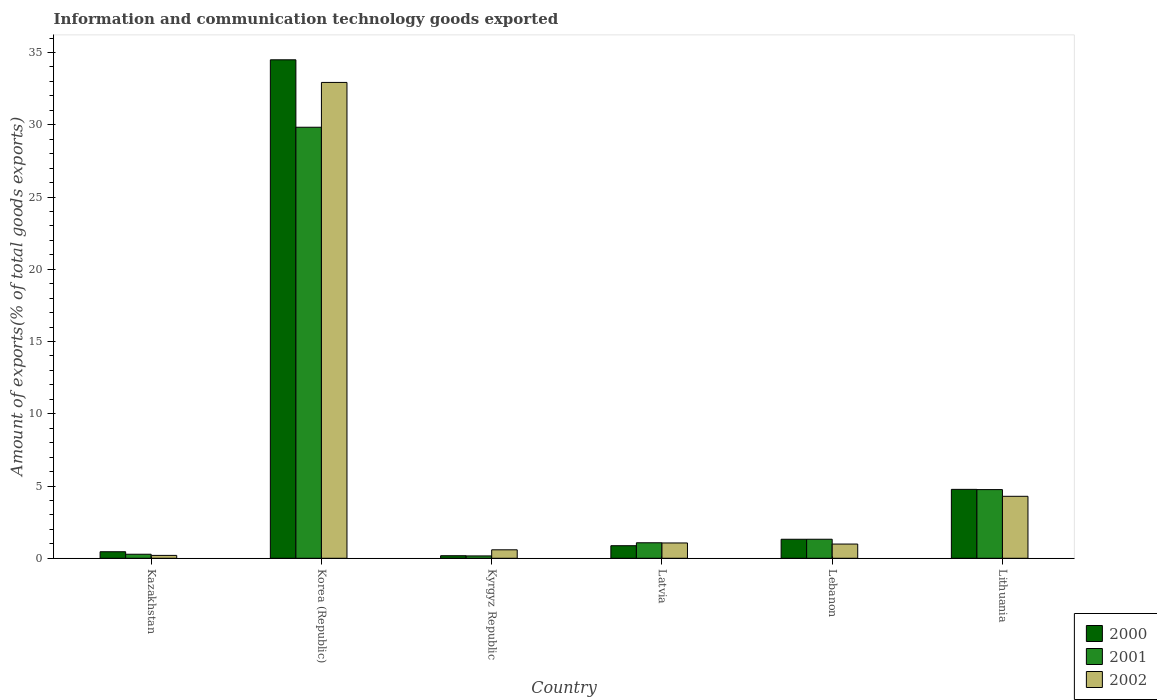Are the number of bars per tick equal to the number of legend labels?
Keep it short and to the point. Yes. How many bars are there on the 2nd tick from the left?
Your answer should be compact. 3. How many bars are there on the 5th tick from the right?
Offer a very short reply. 3. What is the label of the 3rd group of bars from the left?
Keep it short and to the point. Kyrgyz Republic. In how many cases, is the number of bars for a given country not equal to the number of legend labels?
Provide a short and direct response. 0. What is the amount of goods exported in 2002 in Korea (Republic)?
Ensure brevity in your answer.  32.93. Across all countries, what is the maximum amount of goods exported in 2001?
Provide a short and direct response. 29.83. Across all countries, what is the minimum amount of goods exported in 2001?
Your answer should be very brief. 0.16. In which country was the amount of goods exported in 2002 maximum?
Offer a very short reply. Korea (Republic). In which country was the amount of goods exported in 2002 minimum?
Your answer should be very brief. Kazakhstan. What is the total amount of goods exported in 2000 in the graph?
Keep it short and to the point. 42.08. What is the difference between the amount of goods exported in 2001 in Kazakhstan and that in Lithuania?
Ensure brevity in your answer.  -4.47. What is the difference between the amount of goods exported in 2002 in Lithuania and the amount of goods exported in 2000 in Lebanon?
Your answer should be compact. 2.97. What is the average amount of goods exported in 2002 per country?
Keep it short and to the point. 6.67. What is the difference between the amount of goods exported of/in 2001 and amount of goods exported of/in 2002 in Kazakhstan?
Keep it short and to the point. 0.08. What is the ratio of the amount of goods exported in 2002 in Kazakhstan to that in Kyrgyz Republic?
Provide a succinct answer. 0.34. Is the amount of goods exported in 2001 in Korea (Republic) less than that in Latvia?
Offer a terse response. No. What is the difference between the highest and the second highest amount of goods exported in 2000?
Offer a very short reply. -33.18. What is the difference between the highest and the lowest amount of goods exported in 2002?
Provide a succinct answer. 32.73. In how many countries, is the amount of goods exported in 2000 greater than the average amount of goods exported in 2000 taken over all countries?
Your response must be concise. 1. What does the 3rd bar from the left in Lithuania represents?
Offer a terse response. 2002. What does the 3rd bar from the right in Kazakhstan represents?
Your response must be concise. 2000. Is it the case that in every country, the sum of the amount of goods exported in 2002 and amount of goods exported in 2001 is greater than the amount of goods exported in 2000?
Offer a very short reply. Yes. How many bars are there?
Give a very brief answer. 18. Are all the bars in the graph horizontal?
Make the answer very short. No. Does the graph contain grids?
Provide a succinct answer. No. Where does the legend appear in the graph?
Give a very brief answer. Bottom right. How many legend labels are there?
Your answer should be very brief. 3. How are the legend labels stacked?
Provide a short and direct response. Vertical. What is the title of the graph?
Ensure brevity in your answer.  Information and communication technology goods exported. Does "1960" appear as one of the legend labels in the graph?
Offer a terse response. No. What is the label or title of the Y-axis?
Offer a terse response. Amount of exports(% of total goods exports). What is the Amount of exports(% of total goods exports) in 2000 in Kazakhstan?
Provide a short and direct response. 0.45. What is the Amount of exports(% of total goods exports) in 2001 in Kazakhstan?
Ensure brevity in your answer.  0.28. What is the Amount of exports(% of total goods exports) in 2002 in Kazakhstan?
Your answer should be very brief. 0.2. What is the Amount of exports(% of total goods exports) in 2000 in Korea (Republic)?
Your answer should be very brief. 34.5. What is the Amount of exports(% of total goods exports) in 2001 in Korea (Republic)?
Ensure brevity in your answer.  29.83. What is the Amount of exports(% of total goods exports) in 2002 in Korea (Republic)?
Provide a succinct answer. 32.93. What is the Amount of exports(% of total goods exports) in 2000 in Kyrgyz Republic?
Make the answer very short. 0.18. What is the Amount of exports(% of total goods exports) in 2001 in Kyrgyz Republic?
Give a very brief answer. 0.16. What is the Amount of exports(% of total goods exports) in 2002 in Kyrgyz Republic?
Provide a short and direct response. 0.59. What is the Amount of exports(% of total goods exports) of 2000 in Latvia?
Keep it short and to the point. 0.87. What is the Amount of exports(% of total goods exports) in 2001 in Latvia?
Your answer should be compact. 1.07. What is the Amount of exports(% of total goods exports) of 2002 in Latvia?
Offer a terse response. 1.06. What is the Amount of exports(% of total goods exports) of 2000 in Lebanon?
Offer a terse response. 1.32. What is the Amount of exports(% of total goods exports) in 2001 in Lebanon?
Your answer should be very brief. 1.32. What is the Amount of exports(% of total goods exports) in 2002 in Lebanon?
Give a very brief answer. 0.98. What is the Amount of exports(% of total goods exports) in 2000 in Lithuania?
Your response must be concise. 4.77. What is the Amount of exports(% of total goods exports) of 2001 in Lithuania?
Provide a short and direct response. 4.75. What is the Amount of exports(% of total goods exports) of 2002 in Lithuania?
Provide a short and direct response. 4.29. Across all countries, what is the maximum Amount of exports(% of total goods exports) in 2000?
Provide a short and direct response. 34.5. Across all countries, what is the maximum Amount of exports(% of total goods exports) in 2001?
Offer a very short reply. 29.83. Across all countries, what is the maximum Amount of exports(% of total goods exports) in 2002?
Your answer should be compact. 32.93. Across all countries, what is the minimum Amount of exports(% of total goods exports) in 2000?
Your response must be concise. 0.18. Across all countries, what is the minimum Amount of exports(% of total goods exports) in 2001?
Your response must be concise. 0.16. Across all countries, what is the minimum Amount of exports(% of total goods exports) in 2002?
Offer a terse response. 0.2. What is the total Amount of exports(% of total goods exports) of 2000 in the graph?
Provide a short and direct response. 42.08. What is the total Amount of exports(% of total goods exports) in 2001 in the graph?
Your answer should be very brief. 37.41. What is the total Amount of exports(% of total goods exports) in 2002 in the graph?
Your answer should be very brief. 40.05. What is the difference between the Amount of exports(% of total goods exports) of 2000 in Kazakhstan and that in Korea (Republic)?
Provide a short and direct response. -34.04. What is the difference between the Amount of exports(% of total goods exports) of 2001 in Kazakhstan and that in Korea (Republic)?
Your answer should be very brief. -29.55. What is the difference between the Amount of exports(% of total goods exports) of 2002 in Kazakhstan and that in Korea (Republic)?
Provide a succinct answer. -32.73. What is the difference between the Amount of exports(% of total goods exports) in 2000 in Kazakhstan and that in Kyrgyz Republic?
Offer a very short reply. 0.28. What is the difference between the Amount of exports(% of total goods exports) in 2001 in Kazakhstan and that in Kyrgyz Republic?
Your response must be concise. 0.12. What is the difference between the Amount of exports(% of total goods exports) of 2002 in Kazakhstan and that in Kyrgyz Republic?
Give a very brief answer. -0.39. What is the difference between the Amount of exports(% of total goods exports) in 2000 in Kazakhstan and that in Latvia?
Offer a terse response. -0.42. What is the difference between the Amount of exports(% of total goods exports) in 2001 in Kazakhstan and that in Latvia?
Give a very brief answer. -0.79. What is the difference between the Amount of exports(% of total goods exports) of 2002 in Kazakhstan and that in Latvia?
Provide a short and direct response. -0.86. What is the difference between the Amount of exports(% of total goods exports) in 2000 in Kazakhstan and that in Lebanon?
Offer a terse response. -0.86. What is the difference between the Amount of exports(% of total goods exports) of 2001 in Kazakhstan and that in Lebanon?
Give a very brief answer. -1.04. What is the difference between the Amount of exports(% of total goods exports) of 2002 in Kazakhstan and that in Lebanon?
Provide a short and direct response. -0.78. What is the difference between the Amount of exports(% of total goods exports) in 2000 in Kazakhstan and that in Lithuania?
Keep it short and to the point. -4.32. What is the difference between the Amount of exports(% of total goods exports) of 2001 in Kazakhstan and that in Lithuania?
Offer a terse response. -4.47. What is the difference between the Amount of exports(% of total goods exports) in 2002 in Kazakhstan and that in Lithuania?
Provide a short and direct response. -4.09. What is the difference between the Amount of exports(% of total goods exports) of 2000 in Korea (Republic) and that in Kyrgyz Republic?
Give a very brief answer. 34.32. What is the difference between the Amount of exports(% of total goods exports) of 2001 in Korea (Republic) and that in Kyrgyz Republic?
Your answer should be very brief. 29.67. What is the difference between the Amount of exports(% of total goods exports) of 2002 in Korea (Republic) and that in Kyrgyz Republic?
Your answer should be compact. 32.34. What is the difference between the Amount of exports(% of total goods exports) in 2000 in Korea (Republic) and that in Latvia?
Ensure brevity in your answer.  33.63. What is the difference between the Amount of exports(% of total goods exports) of 2001 in Korea (Republic) and that in Latvia?
Your response must be concise. 28.76. What is the difference between the Amount of exports(% of total goods exports) in 2002 in Korea (Republic) and that in Latvia?
Ensure brevity in your answer.  31.87. What is the difference between the Amount of exports(% of total goods exports) of 2000 in Korea (Republic) and that in Lebanon?
Give a very brief answer. 33.18. What is the difference between the Amount of exports(% of total goods exports) of 2001 in Korea (Republic) and that in Lebanon?
Offer a terse response. 28.51. What is the difference between the Amount of exports(% of total goods exports) of 2002 in Korea (Republic) and that in Lebanon?
Your response must be concise. 31.95. What is the difference between the Amount of exports(% of total goods exports) in 2000 in Korea (Republic) and that in Lithuania?
Your answer should be very brief. 29.73. What is the difference between the Amount of exports(% of total goods exports) of 2001 in Korea (Republic) and that in Lithuania?
Give a very brief answer. 25.08. What is the difference between the Amount of exports(% of total goods exports) of 2002 in Korea (Republic) and that in Lithuania?
Keep it short and to the point. 28.64. What is the difference between the Amount of exports(% of total goods exports) of 2000 in Kyrgyz Republic and that in Latvia?
Ensure brevity in your answer.  -0.69. What is the difference between the Amount of exports(% of total goods exports) in 2001 in Kyrgyz Republic and that in Latvia?
Offer a terse response. -0.91. What is the difference between the Amount of exports(% of total goods exports) of 2002 in Kyrgyz Republic and that in Latvia?
Provide a short and direct response. -0.47. What is the difference between the Amount of exports(% of total goods exports) in 2000 in Kyrgyz Republic and that in Lebanon?
Provide a succinct answer. -1.14. What is the difference between the Amount of exports(% of total goods exports) in 2001 in Kyrgyz Republic and that in Lebanon?
Provide a short and direct response. -1.15. What is the difference between the Amount of exports(% of total goods exports) in 2002 in Kyrgyz Republic and that in Lebanon?
Your answer should be compact. -0.4. What is the difference between the Amount of exports(% of total goods exports) in 2000 in Kyrgyz Republic and that in Lithuania?
Make the answer very short. -4.59. What is the difference between the Amount of exports(% of total goods exports) of 2001 in Kyrgyz Republic and that in Lithuania?
Ensure brevity in your answer.  -4.59. What is the difference between the Amount of exports(% of total goods exports) of 2002 in Kyrgyz Republic and that in Lithuania?
Give a very brief answer. -3.7. What is the difference between the Amount of exports(% of total goods exports) in 2000 in Latvia and that in Lebanon?
Ensure brevity in your answer.  -0.45. What is the difference between the Amount of exports(% of total goods exports) in 2001 in Latvia and that in Lebanon?
Your response must be concise. -0.24. What is the difference between the Amount of exports(% of total goods exports) in 2002 in Latvia and that in Lebanon?
Make the answer very short. 0.08. What is the difference between the Amount of exports(% of total goods exports) of 2000 in Latvia and that in Lithuania?
Ensure brevity in your answer.  -3.9. What is the difference between the Amount of exports(% of total goods exports) of 2001 in Latvia and that in Lithuania?
Your answer should be very brief. -3.68. What is the difference between the Amount of exports(% of total goods exports) in 2002 in Latvia and that in Lithuania?
Provide a short and direct response. -3.23. What is the difference between the Amount of exports(% of total goods exports) of 2000 in Lebanon and that in Lithuania?
Give a very brief answer. -3.45. What is the difference between the Amount of exports(% of total goods exports) of 2001 in Lebanon and that in Lithuania?
Your answer should be compact. -3.44. What is the difference between the Amount of exports(% of total goods exports) of 2002 in Lebanon and that in Lithuania?
Your answer should be very brief. -3.31. What is the difference between the Amount of exports(% of total goods exports) in 2000 in Kazakhstan and the Amount of exports(% of total goods exports) in 2001 in Korea (Republic)?
Provide a short and direct response. -29.38. What is the difference between the Amount of exports(% of total goods exports) of 2000 in Kazakhstan and the Amount of exports(% of total goods exports) of 2002 in Korea (Republic)?
Keep it short and to the point. -32.48. What is the difference between the Amount of exports(% of total goods exports) of 2001 in Kazakhstan and the Amount of exports(% of total goods exports) of 2002 in Korea (Republic)?
Make the answer very short. -32.65. What is the difference between the Amount of exports(% of total goods exports) in 2000 in Kazakhstan and the Amount of exports(% of total goods exports) in 2001 in Kyrgyz Republic?
Your response must be concise. 0.29. What is the difference between the Amount of exports(% of total goods exports) in 2000 in Kazakhstan and the Amount of exports(% of total goods exports) in 2002 in Kyrgyz Republic?
Offer a terse response. -0.13. What is the difference between the Amount of exports(% of total goods exports) of 2001 in Kazakhstan and the Amount of exports(% of total goods exports) of 2002 in Kyrgyz Republic?
Give a very brief answer. -0.31. What is the difference between the Amount of exports(% of total goods exports) in 2000 in Kazakhstan and the Amount of exports(% of total goods exports) in 2001 in Latvia?
Ensure brevity in your answer.  -0.62. What is the difference between the Amount of exports(% of total goods exports) in 2000 in Kazakhstan and the Amount of exports(% of total goods exports) in 2002 in Latvia?
Give a very brief answer. -0.61. What is the difference between the Amount of exports(% of total goods exports) of 2001 in Kazakhstan and the Amount of exports(% of total goods exports) of 2002 in Latvia?
Make the answer very short. -0.78. What is the difference between the Amount of exports(% of total goods exports) of 2000 in Kazakhstan and the Amount of exports(% of total goods exports) of 2001 in Lebanon?
Make the answer very short. -0.86. What is the difference between the Amount of exports(% of total goods exports) of 2000 in Kazakhstan and the Amount of exports(% of total goods exports) of 2002 in Lebanon?
Keep it short and to the point. -0.53. What is the difference between the Amount of exports(% of total goods exports) of 2001 in Kazakhstan and the Amount of exports(% of total goods exports) of 2002 in Lebanon?
Offer a very short reply. -0.7. What is the difference between the Amount of exports(% of total goods exports) of 2000 in Kazakhstan and the Amount of exports(% of total goods exports) of 2002 in Lithuania?
Provide a short and direct response. -3.84. What is the difference between the Amount of exports(% of total goods exports) in 2001 in Kazakhstan and the Amount of exports(% of total goods exports) in 2002 in Lithuania?
Give a very brief answer. -4.01. What is the difference between the Amount of exports(% of total goods exports) of 2000 in Korea (Republic) and the Amount of exports(% of total goods exports) of 2001 in Kyrgyz Republic?
Give a very brief answer. 34.33. What is the difference between the Amount of exports(% of total goods exports) of 2000 in Korea (Republic) and the Amount of exports(% of total goods exports) of 2002 in Kyrgyz Republic?
Provide a short and direct response. 33.91. What is the difference between the Amount of exports(% of total goods exports) in 2001 in Korea (Republic) and the Amount of exports(% of total goods exports) in 2002 in Kyrgyz Republic?
Your answer should be compact. 29.24. What is the difference between the Amount of exports(% of total goods exports) in 2000 in Korea (Republic) and the Amount of exports(% of total goods exports) in 2001 in Latvia?
Give a very brief answer. 33.42. What is the difference between the Amount of exports(% of total goods exports) in 2000 in Korea (Republic) and the Amount of exports(% of total goods exports) in 2002 in Latvia?
Provide a succinct answer. 33.44. What is the difference between the Amount of exports(% of total goods exports) in 2001 in Korea (Republic) and the Amount of exports(% of total goods exports) in 2002 in Latvia?
Your response must be concise. 28.77. What is the difference between the Amount of exports(% of total goods exports) of 2000 in Korea (Republic) and the Amount of exports(% of total goods exports) of 2001 in Lebanon?
Provide a succinct answer. 33.18. What is the difference between the Amount of exports(% of total goods exports) in 2000 in Korea (Republic) and the Amount of exports(% of total goods exports) in 2002 in Lebanon?
Provide a short and direct response. 33.51. What is the difference between the Amount of exports(% of total goods exports) in 2001 in Korea (Republic) and the Amount of exports(% of total goods exports) in 2002 in Lebanon?
Keep it short and to the point. 28.84. What is the difference between the Amount of exports(% of total goods exports) in 2000 in Korea (Republic) and the Amount of exports(% of total goods exports) in 2001 in Lithuania?
Offer a very short reply. 29.74. What is the difference between the Amount of exports(% of total goods exports) in 2000 in Korea (Republic) and the Amount of exports(% of total goods exports) in 2002 in Lithuania?
Provide a succinct answer. 30.21. What is the difference between the Amount of exports(% of total goods exports) in 2001 in Korea (Republic) and the Amount of exports(% of total goods exports) in 2002 in Lithuania?
Provide a short and direct response. 25.54. What is the difference between the Amount of exports(% of total goods exports) of 2000 in Kyrgyz Republic and the Amount of exports(% of total goods exports) of 2001 in Latvia?
Keep it short and to the point. -0.9. What is the difference between the Amount of exports(% of total goods exports) in 2000 in Kyrgyz Republic and the Amount of exports(% of total goods exports) in 2002 in Latvia?
Provide a short and direct response. -0.88. What is the difference between the Amount of exports(% of total goods exports) in 2001 in Kyrgyz Republic and the Amount of exports(% of total goods exports) in 2002 in Latvia?
Offer a terse response. -0.9. What is the difference between the Amount of exports(% of total goods exports) of 2000 in Kyrgyz Republic and the Amount of exports(% of total goods exports) of 2001 in Lebanon?
Provide a short and direct response. -1.14. What is the difference between the Amount of exports(% of total goods exports) of 2000 in Kyrgyz Republic and the Amount of exports(% of total goods exports) of 2002 in Lebanon?
Your response must be concise. -0.81. What is the difference between the Amount of exports(% of total goods exports) of 2001 in Kyrgyz Republic and the Amount of exports(% of total goods exports) of 2002 in Lebanon?
Give a very brief answer. -0.82. What is the difference between the Amount of exports(% of total goods exports) in 2000 in Kyrgyz Republic and the Amount of exports(% of total goods exports) in 2001 in Lithuania?
Your response must be concise. -4.58. What is the difference between the Amount of exports(% of total goods exports) in 2000 in Kyrgyz Republic and the Amount of exports(% of total goods exports) in 2002 in Lithuania?
Give a very brief answer. -4.11. What is the difference between the Amount of exports(% of total goods exports) of 2001 in Kyrgyz Republic and the Amount of exports(% of total goods exports) of 2002 in Lithuania?
Make the answer very short. -4.13. What is the difference between the Amount of exports(% of total goods exports) in 2000 in Latvia and the Amount of exports(% of total goods exports) in 2001 in Lebanon?
Provide a succinct answer. -0.45. What is the difference between the Amount of exports(% of total goods exports) in 2000 in Latvia and the Amount of exports(% of total goods exports) in 2002 in Lebanon?
Your answer should be compact. -0.11. What is the difference between the Amount of exports(% of total goods exports) in 2001 in Latvia and the Amount of exports(% of total goods exports) in 2002 in Lebanon?
Keep it short and to the point. 0.09. What is the difference between the Amount of exports(% of total goods exports) of 2000 in Latvia and the Amount of exports(% of total goods exports) of 2001 in Lithuania?
Ensure brevity in your answer.  -3.88. What is the difference between the Amount of exports(% of total goods exports) of 2000 in Latvia and the Amount of exports(% of total goods exports) of 2002 in Lithuania?
Your answer should be very brief. -3.42. What is the difference between the Amount of exports(% of total goods exports) of 2001 in Latvia and the Amount of exports(% of total goods exports) of 2002 in Lithuania?
Your answer should be compact. -3.22. What is the difference between the Amount of exports(% of total goods exports) of 2000 in Lebanon and the Amount of exports(% of total goods exports) of 2001 in Lithuania?
Your answer should be very brief. -3.44. What is the difference between the Amount of exports(% of total goods exports) of 2000 in Lebanon and the Amount of exports(% of total goods exports) of 2002 in Lithuania?
Provide a succinct answer. -2.97. What is the difference between the Amount of exports(% of total goods exports) of 2001 in Lebanon and the Amount of exports(% of total goods exports) of 2002 in Lithuania?
Ensure brevity in your answer.  -2.97. What is the average Amount of exports(% of total goods exports) in 2000 per country?
Ensure brevity in your answer.  7.01. What is the average Amount of exports(% of total goods exports) in 2001 per country?
Make the answer very short. 6.24. What is the average Amount of exports(% of total goods exports) in 2002 per country?
Your answer should be compact. 6.67. What is the difference between the Amount of exports(% of total goods exports) in 2000 and Amount of exports(% of total goods exports) in 2001 in Kazakhstan?
Your answer should be compact. 0.17. What is the difference between the Amount of exports(% of total goods exports) of 2000 and Amount of exports(% of total goods exports) of 2002 in Kazakhstan?
Your answer should be compact. 0.25. What is the difference between the Amount of exports(% of total goods exports) of 2001 and Amount of exports(% of total goods exports) of 2002 in Kazakhstan?
Provide a short and direct response. 0.08. What is the difference between the Amount of exports(% of total goods exports) in 2000 and Amount of exports(% of total goods exports) in 2001 in Korea (Republic)?
Offer a very short reply. 4.67. What is the difference between the Amount of exports(% of total goods exports) of 2000 and Amount of exports(% of total goods exports) of 2002 in Korea (Republic)?
Make the answer very short. 1.57. What is the difference between the Amount of exports(% of total goods exports) in 2001 and Amount of exports(% of total goods exports) in 2002 in Korea (Republic)?
Your answer should be compact. -3.1. What is the difference between the Amount of exports(% of total goods exports) in 2000 and Amount of exports(% of total goods exports) in 2001 in Kyrgyz Republic?
Provide a short and direct response. 0.01. What is the difference between the Amount of exports(% of total goods exports) in 2000 and Amount of exports(% of total goods exports) in 2002 in Kyrgyz Republic?
Ensure brevity in your answer.  -0.41. What is the difference between the Amount of exports(% of total goods exports) of 2001 and Amount of exports(% of total goods exports) of 2002 in Kyrgyz Republic?
Provide a short and direct response. -0.42. What is the difference between the Amount of exports(% of total goods exports) in 2000 and Amount of exports(% of total goods exports) in 2001 in Latvia?
Your answer should be very brief. -0.2. What is the difference between the Amount of exports(% of total goods exports) of 2000 and Amount of exports(% of total goods exports) of 2002 in Latvia?
Provide a short and direct response. -0.19. What is the difference between the Amount of exports(% of total goods exports) in 2001 and Amount of exports(% of total goods exports) in 2002 in Latvia?
Give a very brief answer. 0.01. What is the difference between the Amount of exports(% of total goods exports) in 2000 and Amount of exports(% of total goods exports) in 2001 in Lebanon?
Provide a short and direct response. -0. What is the difference between the Amount of exports(% of total goods exports) of 2000 and Amount of exports(% of total goods exports) of 2002 in Lebanon?
Provide a short and direct response. 0.33. What is the difference between the Amount of exports(% of total goods exports) in 2001 and Amount of exports(% of total goods exports) in 2002 in Lebanon?
Make the answer very short. 0.33. What is the difference between the Amount of exports(% of total goods exports) in 2000 and Amount of exports(% of total goods exports) in 2001 in Lithuania?
Make the answer very short. 0.02. What is the difference between the Amount of exports(% of total goods exports) in 2000 and Amount of exports(% of total goods exports) in 2002 in Lithuania?
Provide a short and direct response. 0.48. What is the difference between the Amount of exports(% of total goods exports) of 2001 and Amount of exports(% of total goods exports) of 2002 in Lithuania?
Your answer should be compact. 0.46. What is the ratio of the Amount of exports(% of total goods exports) of 2000 in Kazakhstan to that in Korea (Republic)?
Provide a succinct answer. 0.01. What is the ratio of the Amount of exports(% of total goods exports) of 2001 in Kazakhstan to that in Korea (Republic)?
Your response must be concise. 0.01. What is the ratio of the Amount of exports(% of total goods exports) in 2002 in Kazakhstan to that in Korea (Republic)?
Ensure brevity in your answer.  0.01. What is the ratio of the Amount of exports(% of total goods exports) of 2000 in Kazakhstan to that in Kyrgyz Republic?
Your answer should be compact. 2.56. What is the ratio of the Amount of exports(% of total goods exports) of 2001 in Kazakhstan to that in Kyrgyz Republic?
Provide a short and direct response. 1.72. What is the ratio of the Amount of exports(% of total goods exports) in 2002 in Kazakhstan to that in Kyrgyz Republic?
Offer a terse response. 0.34. What is the ratio of the Amount of exports(% of total goods exports) in 2000 in Kazakhstan to that in Latvia?
Give a very brief answer. 0.52. What is the ratio of the Amount of exports(% of total goods exports) in 2001 in Kazakhstan to that in Latvia?
Offer a terse response. 0.26. What is the ratio of the Amount of exports(% of total goods exports) of 2002 in Kazakhstan to that in Latvia?
Give a very brief answer. 0.19. What is the ratio of the Amount of exports(% of total goods exports) in 2000 in Kazakhstan to that in Lebanon?
Offer a terse response. 0.34. What is the ratio of the Amount of exports(% of total goods exports) of 2001 in Kazakhstan to that in Lebanon?
Offer a terse response. 0.21. What is the ratio of the Amount of exports(% of total goods exports) in 2002 in Kazakhstan to that in Lebanon?
Provide a succinct answer. 0.2. What is the ratio of the Amount of exports(% of total goods exports) in 2000 in Kazakhstan to that in Lithuania?
Provide a succinct answer. 0.09. What is the ratio of the Amount of exports(% of total goods exports) in 2001 in Kazakhstan to that in Lithuania?
Your response must be concise. 0.06. What is the ratio of the Amount of exports(% of total goods exports) of 2002 in Kazakhstan to that in Lithuania?
Ensure brevity in your answer.  0.05. What is the ratio of the Amount of exports(% of total goods exports) of 2000 in Korea (Republic) to that in Kyrgyz Republic?
Your answer should be compact. 195.36. What is the ratio of the Amount of exports(% of total goods exports) of 2001 in Korea (Republic) to that in Kyrgyz Republic?
Give a very brief answer. 183.52. What is the ratio of the Amount of exports(% of total goods exports) of 2002 in Korea (Republic) to that in Kyrgyz Republic?
Your response must be concise. 56.21. What is the ratio of the Amount of exports(% of total goods exports) in 2000 in Korea (Republic) to that in Latvia?
Provide a short and direct response. 39.68. What is the ratio of the Amount of exports(% of total goods exports) in 2001 in Korea (Republic) to that in Latvia?
Make the answer very short. 27.82. What is the ratio of the Amount of exports(% of total goods exports) in 2002 in Korea (Republic) to that in Latvia?
Offer a terse response. 31.08. What is the ratio of the Amount of exports(% of total goods exports) of 2000 in Korea (Republic) to that in Lebanon?
Provide a short and direct response. 26.22. What is the ratio of the Amount of exports(% of total goods exports) of 2001 in Korea (Republic) to that in Lebanon?
Give a very brief answer. 22.65. What is the ratio of the Amount of exports(% of total goods exports) of 2002 in Korea (Republic) to that in Lebanon?
Offer a very short reply. 33.48. What is the ratio of the Amount of exports(% of total goods exports) in 2000 in Korea (Republic) to that in Lithuania?
Your answer should be very brief. 7.23. What is the ratio of the Amount of exports(% of total goods exports) in 2001 in Korea (Republic) to that in Lithuania?
Ensure brevity in your answer.  6.28. What is the ratio of the Amount of exports(% of total goods exports) in 2002 in Korea (Republic) to that in Lithuania?
Offer a very short reply. 7.68. What is the ratio of the Amount of exports(% of total goods exports) of 2000 in Kyrgyz Republic to that in Latvia?
Give a very brief answer. 0.2. What is the ratio of the Amount of exports(% of total goods exports) of 2001 in Kyrgyz Republic to that in Latvia?
Your response must be concise. 0.15. What is the ratio of the Amount of exports(% of total goods exports) in 2002 in Kyrgyz Republic to that in Latvia?
Ensure brevity in your answer.  0.55. What is the ratio of the Amount of exports(% of total goods exports) in 2000 in Kyrgyz Republic to that in Lebanon?
Keep it short and to the point. 0.13. What is the ratio of the Amount of exports(% of total goods exports) in 2001 in Kyrgyz Republic to that in Lebanon?
Make the answer very short. 0.12. What is the ratio of the Amount of exports(% of total goods exports) in 2002 in Kyrgyz Republic to that in Lebanon?
Your answer should be compact. 0.6. What is the ratio of the Amount of exports(% of total goods exports) of 2000 in Kyrgyz Republic to that in Lithuania?
Provide a short and direct response. 0.04. What is the ratio of the Amount of exports(% of total goods exports) in 2001 in Kyrgyz Republic to that in Lithuania?
Provide a short and direct response. 0.03. What is the ratio of the Amount of exports(% of total goods exports) in 2002 in Kyrgyz Republic to that in Lithuania?
Offer a very short reply. 0.14. What is the ratio of the Amount of exports(% of total goods exports) in 2000 in Latvia to that in Lebanon?
Make the answer very short. 0.66. What is the ratio of the Amount of exports(% of total goods exports) of 2001 in Latvia to that in Lebanon?
Offer a very short reply. 0.81. What is the ratio of the Amount of exports(% of total goods exports) in 2002 in Latvia to that in Lebanon?
Offer a very short reply. 1.08. What is the ratio of the Amount of exports(% of total goods exports) of 2000 in Latvia to that in Lithuania?
Your response must be concise. 0.18. What is the ratio of the Amount of exports(% of total goods exports) of 2001 in Latvia to that in Lithuania?
Offer a terse response. 0.23. What is the ratio of the Amount of exports(% of total goods exports) in 2002 in Latvia to that in Lithuania?
Your response must be concise. 0.25. What is the ratio of the Amount of exports(% of total goods exports) in 2000 in Lebanon to that in Lithuania?
Give a very brief answer. 0.28. What is the ratio of the Amount of exports(% of total goods exports) of 2001 in Lebanon to that in Lithuania?
Your answer should be very brief. 0.28. What is the ratio of the Amount of exports(% of total goods exports) of 2002 in Lebanon to that in Lithuania?
Ensure brevity in your answer.  0.23. What is the difference between the highest and the second highest Amount of exports(% of total goods exports) of 2000?
Keep it short and to the point. 29.73. What is the difference between the highest and the second highest Amount of exports(% of total goods exports) of 2001?
Provide a short and direct response. 25.08. What is the difference between the highest and the second highest Amount of exports(% of total goods exports) of 2002?
Your response must be concise. 28.64. What is the difference between the highest and the lowest Amount of exports(% of total goods exports) in 2000?
Provide a short and direct response. 34.32. What is the difference between the highest and the lowest Amount of exports(% of total goods exports) in 2001?
Give a very brief answer. 29.67. What is the difference between the highest and the lowest Amount of exports(% of total goods exports) in 2002?
Make the answer very short. 32.73. 